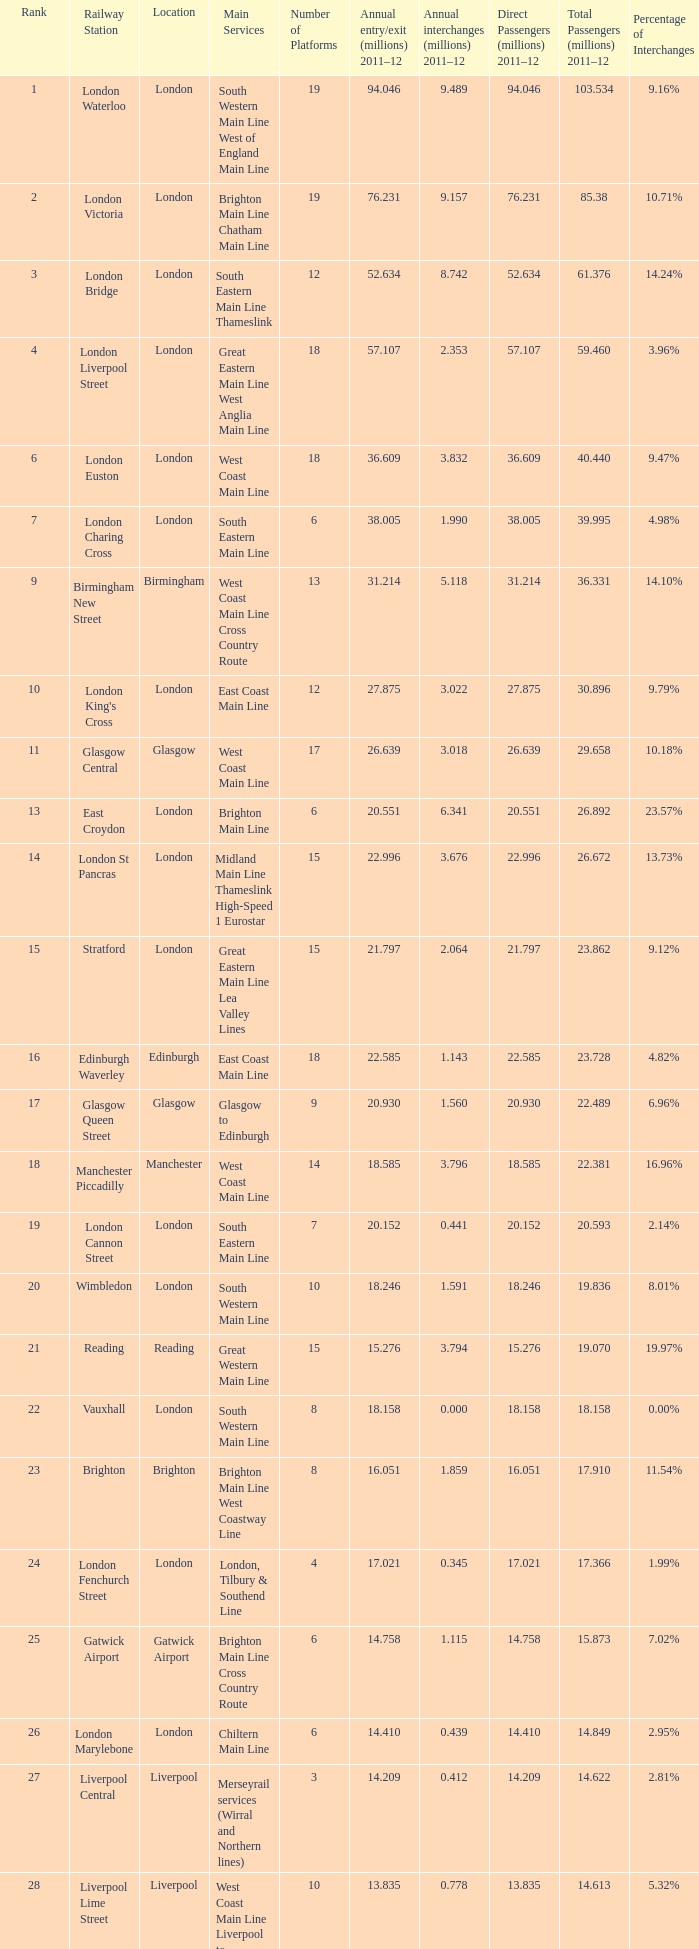Which location has 103.534 million passengers in 2011-12?  London. 